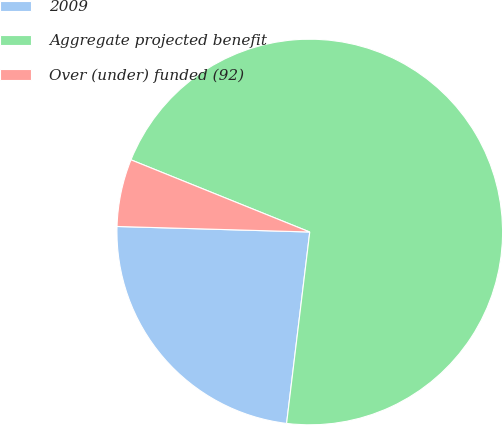Convert chart. <chart><loc_0><loc_0><loc_500><loc_500><pie_chart><fcel>2009<fcel>Aggregate projected benefit<fcel>Over (under) funded (92)<nl><fcel>23.54%<fcel>70.81%<fcel>5.65%<nl></chart> 